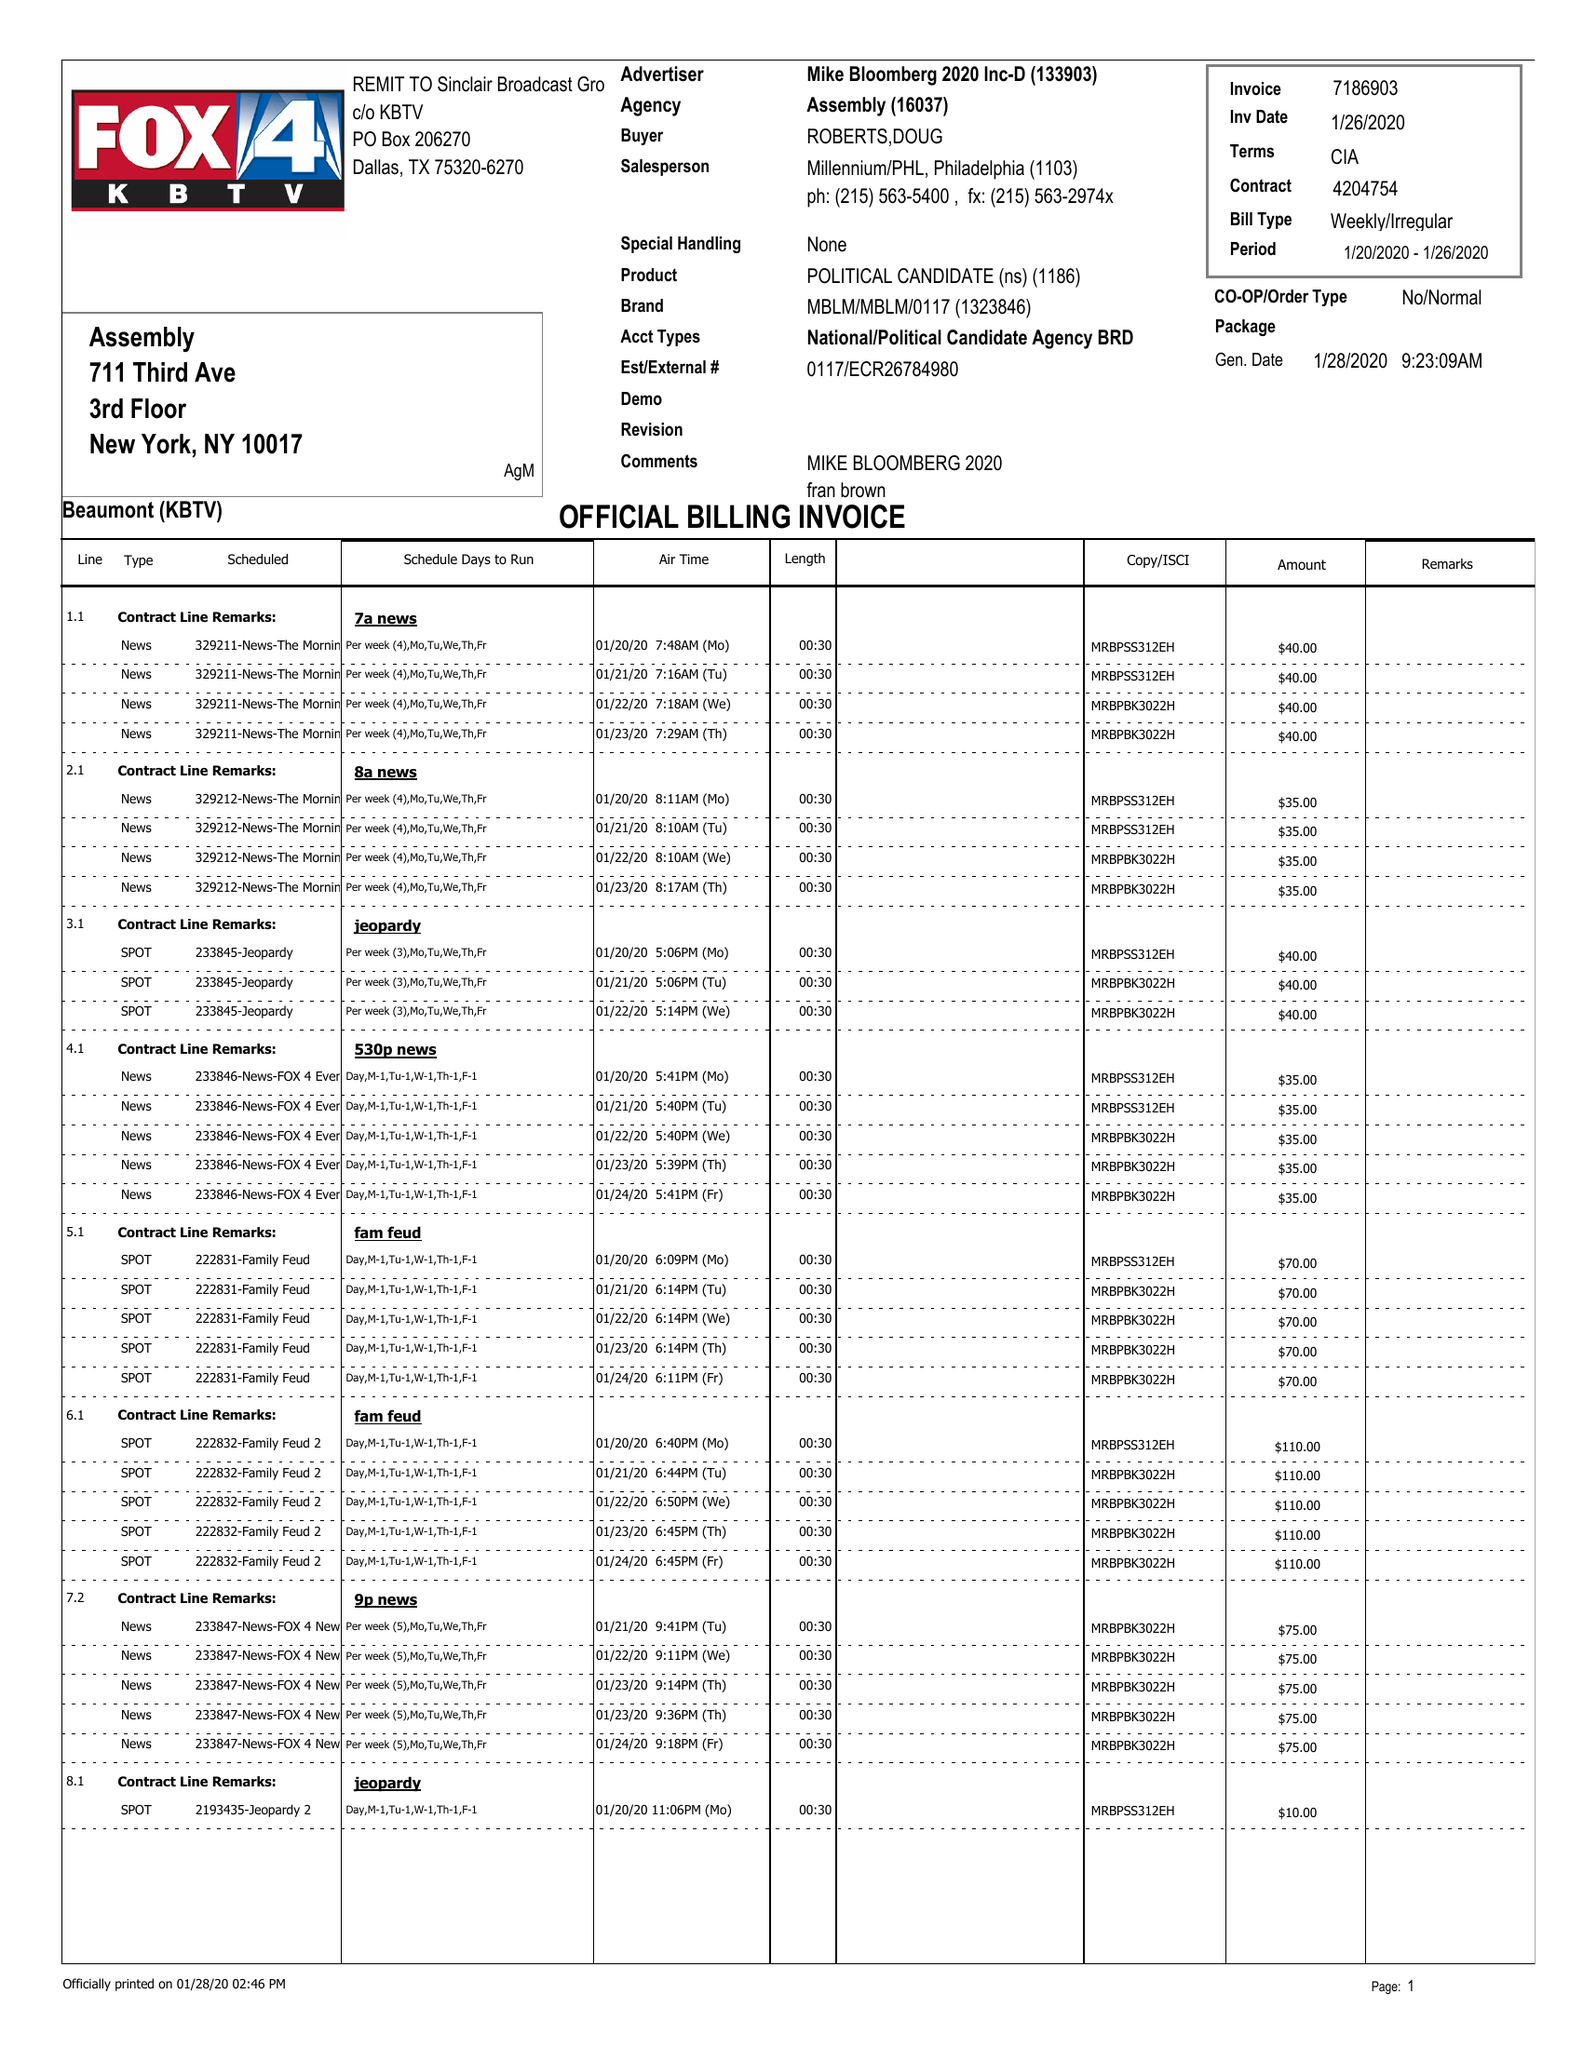What is the value for the flight_to?
Answer the question using a single word or phrase. 01/26/20 